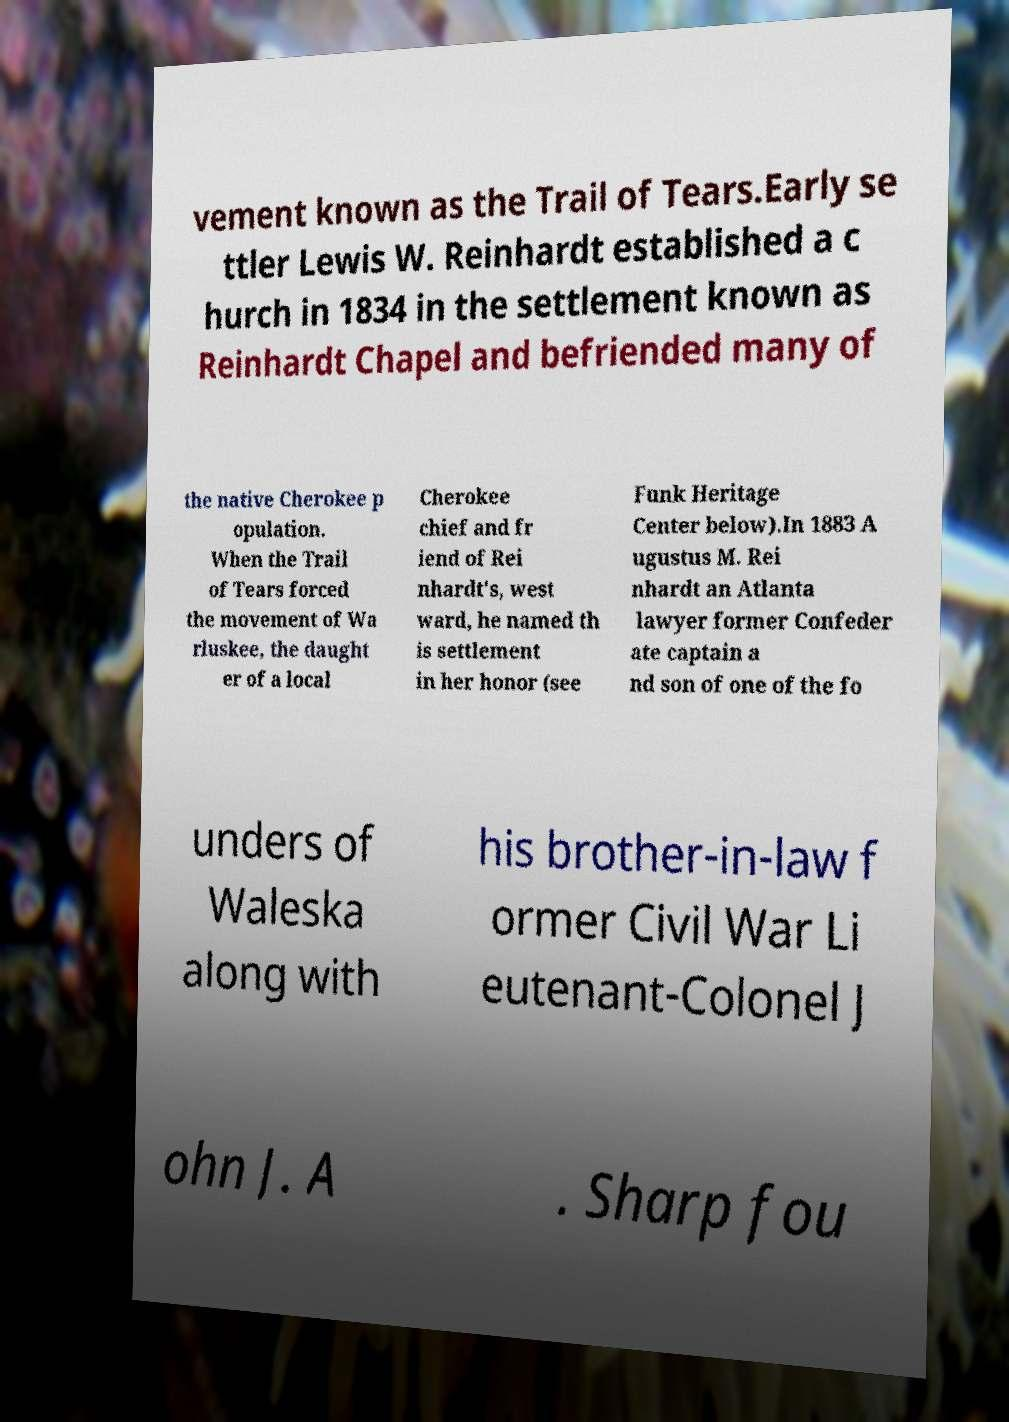I need the written content from this picture converted into text. Can you do that? vement known as the Trail of Tears.Early se ttler Lewis W. Reinhardt established a c hurch in 1834 in the settlement known as Reinhardt Chapel and befriended many of the native Cherokee p opulation. When the Trail of Tears forced the movement of Wa rluskee, the daught er of a local Cherokee chief and fr iend of Rei nhardt's, west ward, he named th is settlement in her honor (see Funk Heritage Center below).In 1883 A ugustus M. Rei nhardt an Atlanta lawyer former Confeder ate captain a nd son of one of the fo unders of Waleska along with his brother-in-law f ormer Civil War Li eutenant-Colonel J ohn J. A . Sharp fou 